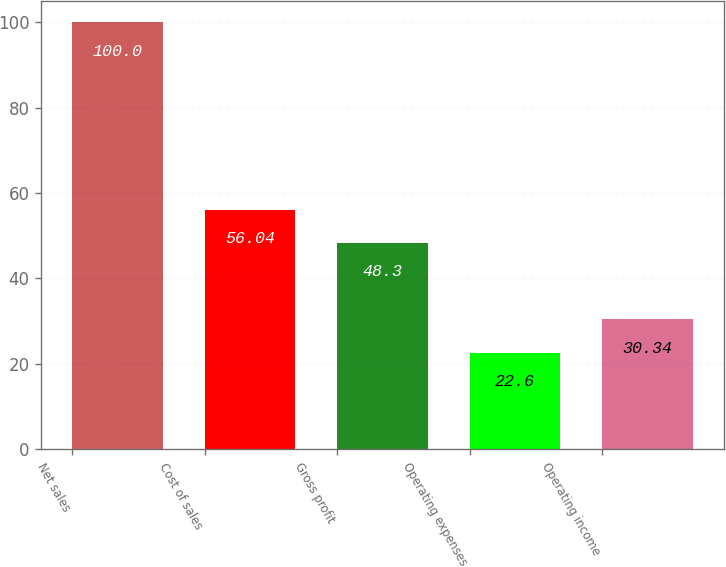<chart> <loc_0><loc_0><loc_500><loc_500><bar_chart><fcel>Net sales<fcel>Cost of sales<fcel>Gross profit<fcel>Operating expenses<fcel>Operating income<nl><fcel>100<fcel>56.04<fcel>48.3<fcel>22.6<fcel>30.34<nl></chart> 